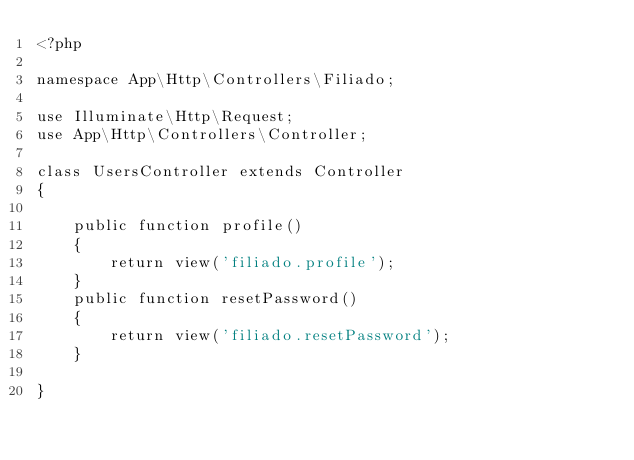<code> <loc_0><loc_0><loc_500><loc_500><_PHP_><?php

namespace App\Http\Controllers\Filiado;

use Illuminate\Http\Request;
use App\Http\Controllers\Controller;

class UsersController extends Controller
{
    
    public function profile()
    {
        return view('filiado.profile');
    }
    public function resetPassword()
    {
        return view('filiado.resetPassword');
    }

}
</code> 